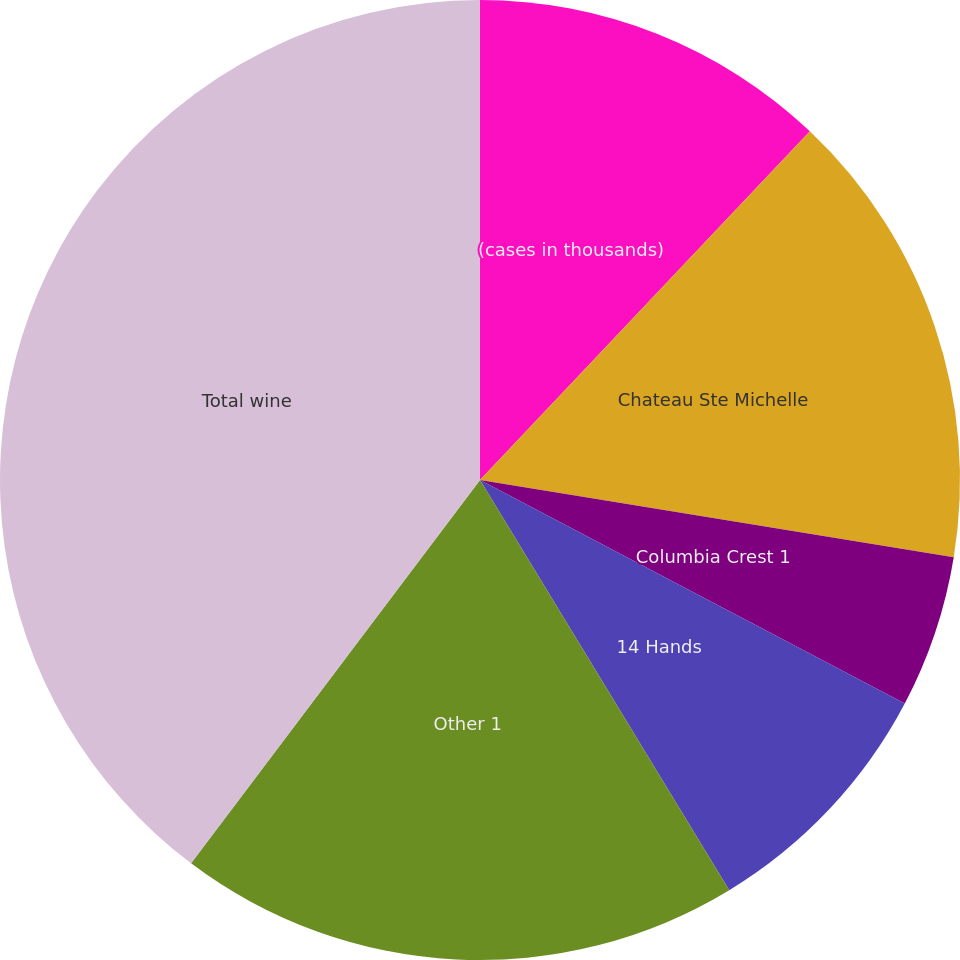Convert chart. <chart><loc_0><loc_0><loc_500><loc_500><pie_chart><fcel>(cases in thousands)<fcel>Chateau Ste Michelle<fcel>Columbia Crest 1<fcel>14 Hands<fcel>Other 1<fcel>Total wine<nl><fcel>12.06%<fcel>15.51%<fcel>5.14%<fcel>8.6%<fcel>18.97%<fcel>39.72%<nl></chart> 